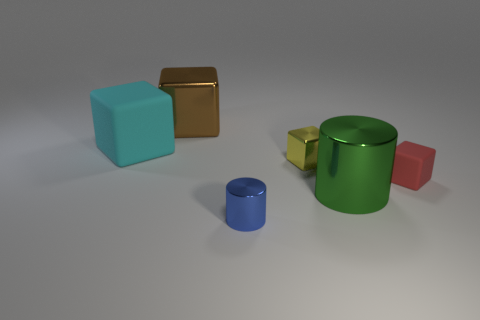What is the color of the tiny shiny thing in front of the tiny block that is to the right of the large thing that is to the right of the big brown shiny cube?
Your response must be concise. Blue. Do the small cylinder and the tiny red block have the same material?
Provide a succinct answer. No. How many purple things are large blocks or tiny spheres?
Ensure brevity in your answer.  0. There is a blue thing; what number of tiny blue metallic things are in front of it?
Offer a very short reply. 0. Is the number of green objects greater than the number of small green matte cylinders?
Keep it short and to the point. Yes. The matte thing that is behind the tiny metallic object behind the large green cylinder is what shape?
Make the answer very short. Cube. Are there more tiny matte objects that are to the right of the brown thing than small brown metal things?
Your answer should be very brief. Yes. How many green cylinders are behind the cube to the right of the tiny yellow shiny block?
Offer a terse response. 0. Does the cylinder that is behind the tiny blue metallic cylinder have the same material as the large block that is to the left of the brown thing?
Give a very brief answer. No. What number of other metallic objects have the same shape as the cyan object?
Give a very brief answer. 2. 